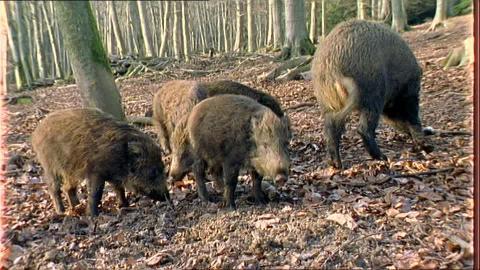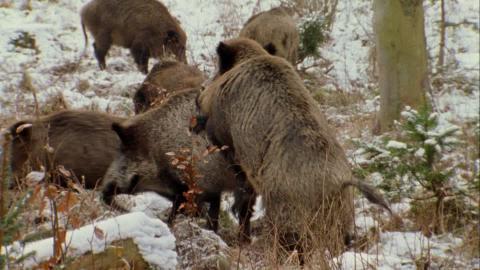The first image is the image on the left, the second image is the image on the right. Considering the images on both sides, is "a warthog is standing facing the camera with piglets near her" valid? Answer yes or no. No. 